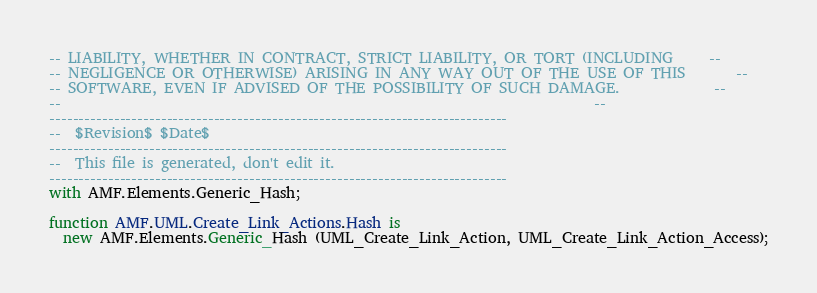<code> <loc_0><loc_0><loc_500><loc_500><_Ada_>-- LIABILITY, WHETHER IN CONTRACT, STRICT LIABILITY, OR TORT (INCLUDING     --
-- NEGLIGENCE OR OTHERWISE) ARISING IN ANY WAY OUT OF THE USE OF THIS       --
-- SOFTWARE, EVEN IF ADVISED OF THE POSSIBILITY OF SUCH DAMAGE.             --
--                                                                          --
------------------------------------------------------------------------------
--  $Revision$ $Date$
------------------------------------------------------------------------------
--  This file is generated, don't edit it.
------------------------------------------------------------------------------
with AMF.Elements.Generic_Hash;

function AMF.UML.Create_Link_Actions.Hash is
  new AMF.Elements.Generic_Hash (UML_Create_Link_Action, UML_Create_Link_Action_Access);
</code> 